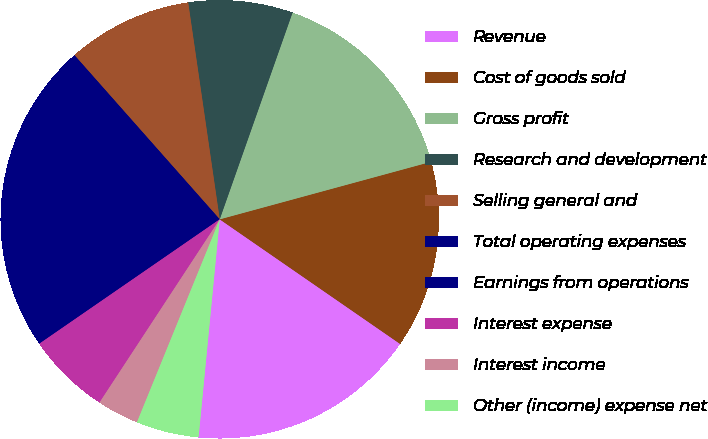Convert chart. <chart><loc_0><loc_0><loc_500><loc_500><pie_chart><fcel>Revenue<fcel>Cost of goods sold<fcel>Gross profit<fcel>Research and development<fcel>Selling general and<fcel>Total operating expenses<fcel>Earnings from operations<fcel>Interest expense<fcel>Interest income<fcel>Other (income) expense net<nl><fcel>16.92%<fcel>13.85%<fcel>15.38%<fcel>7.69%<fcel>9.23%<fcel>10.77%<fcel>12.31%<fcel>6.15%<fcel>3.08%<fcel>4.62%<nl></chart> 